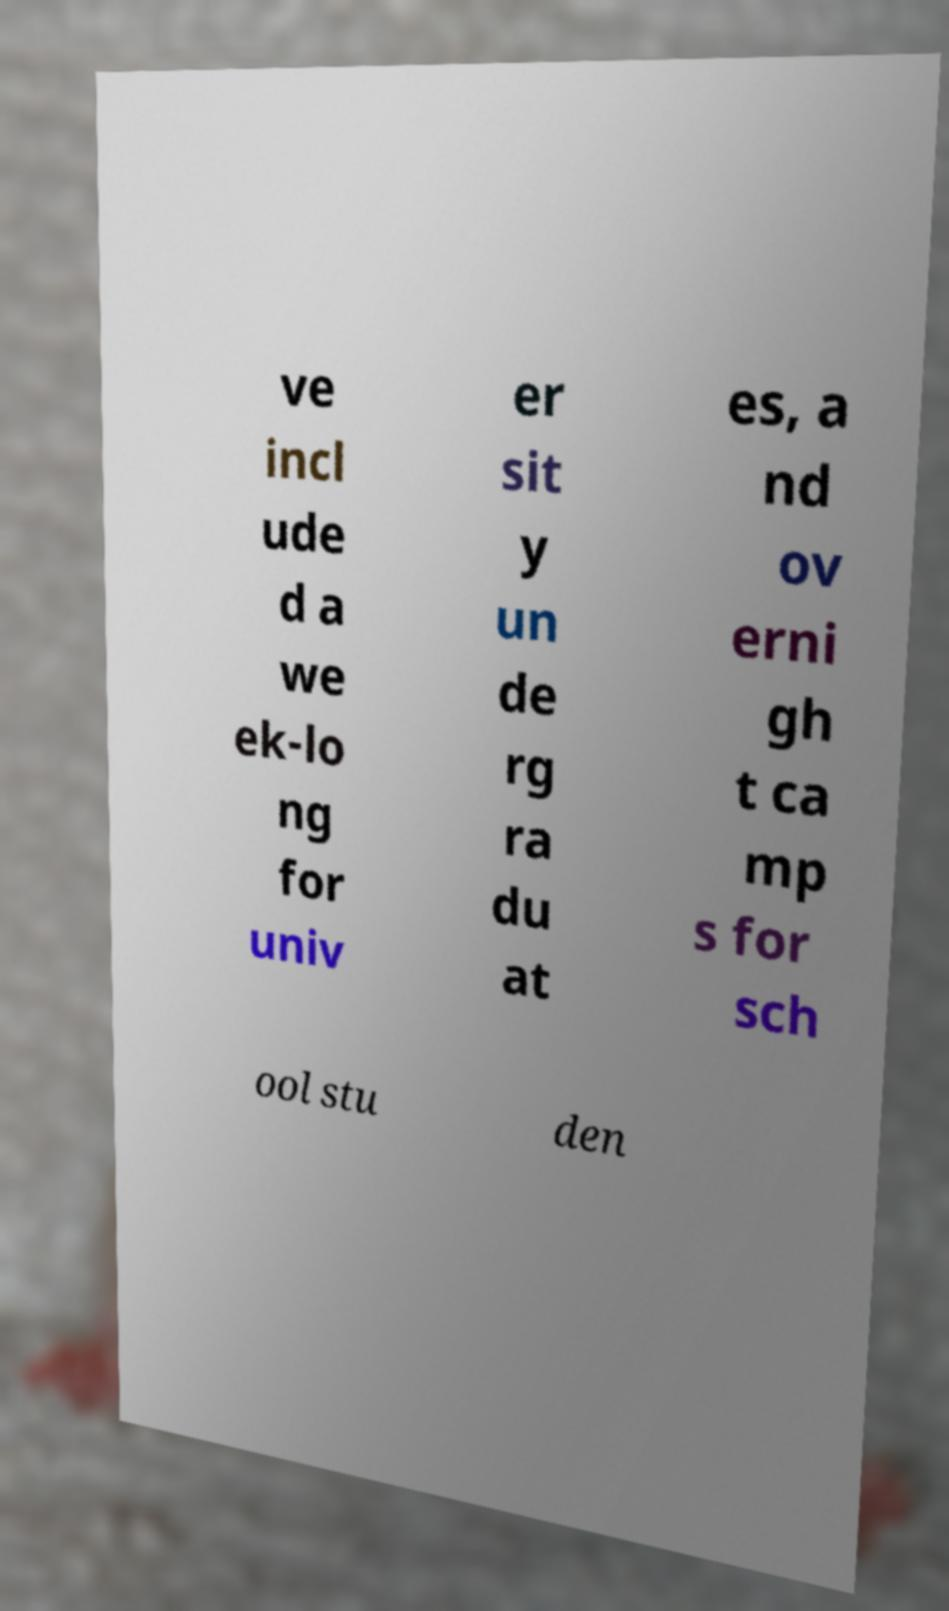Please read and relay the text visible in this image. What does it say? ve incl ude d a we ek-lo ng for univ er sit y un de rg ra du at es, a nd ov erni gh t ca mp s for sch ool stu den 